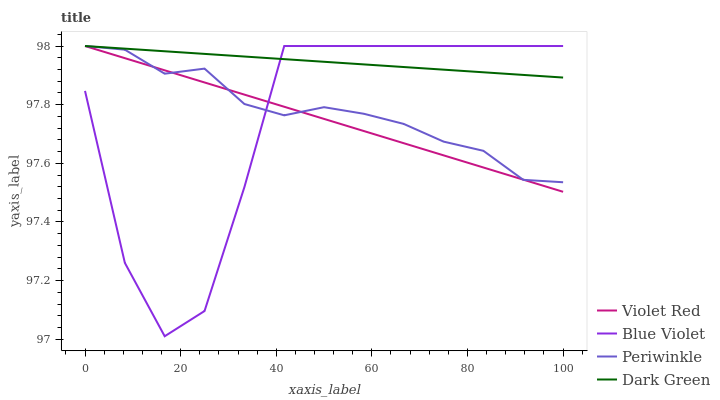Does Blue Violet have the minimum area under the curve?
Answer yes or no. Yes. Does Dark Green have the maximum area under the curve?
Answer yes or no. Yes. Does Periwinkle have the minimum area under the curve?
Answer yes or no. No. Does Periwinkle have the maximum area under the curve?
Answer yes or no. No. Is Violet Red the smoothest?
Answer yes or no. Yes. Is Blue Violet the roughest?
Answer yes or no. Yes. Is Periwinkle the smoothest?
Answer yes or no. No. Is Periwinkle the roughest?
Answer yes or no. No. Does Blue Violet have the lowest value?
Answer yes or no. Yes. Does Periwinkle have the lowest value?
Answer yes or no. No. Does Dark Green have the highest value?
Answer yes or no. Yes. Does Dark Green intersect Blue Violet?
Answer yes or no. Yes. Is Dark Green less than Blue Violet?
Answer yes or no. No. Is Dark Green greater than Blue Violet?
Answer yes or no. No. 